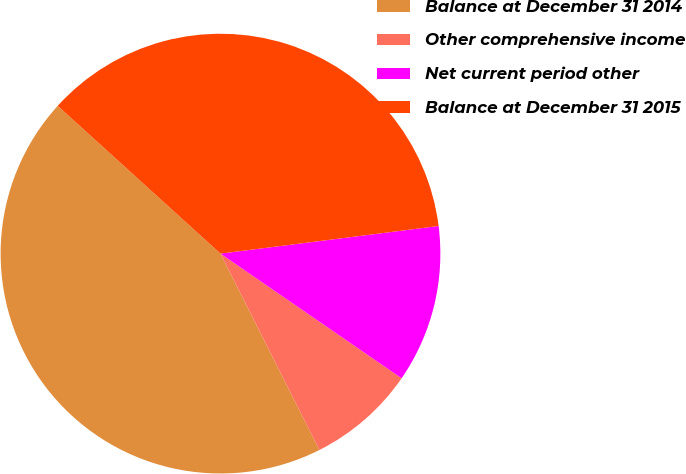Convert chart to OTSL. <chart><loc_0><loc_0><loc_500><loc_500><pie_chart><fcel>Balance at December 31 2014<fcel>Other comprehensive income<fcel>Net current period other<fcel>Balance at December 31 2015<nl><fcel>44.16%<fcel>7.98%<fcel>11.6%<fcel>36.26%<nl></chart> 